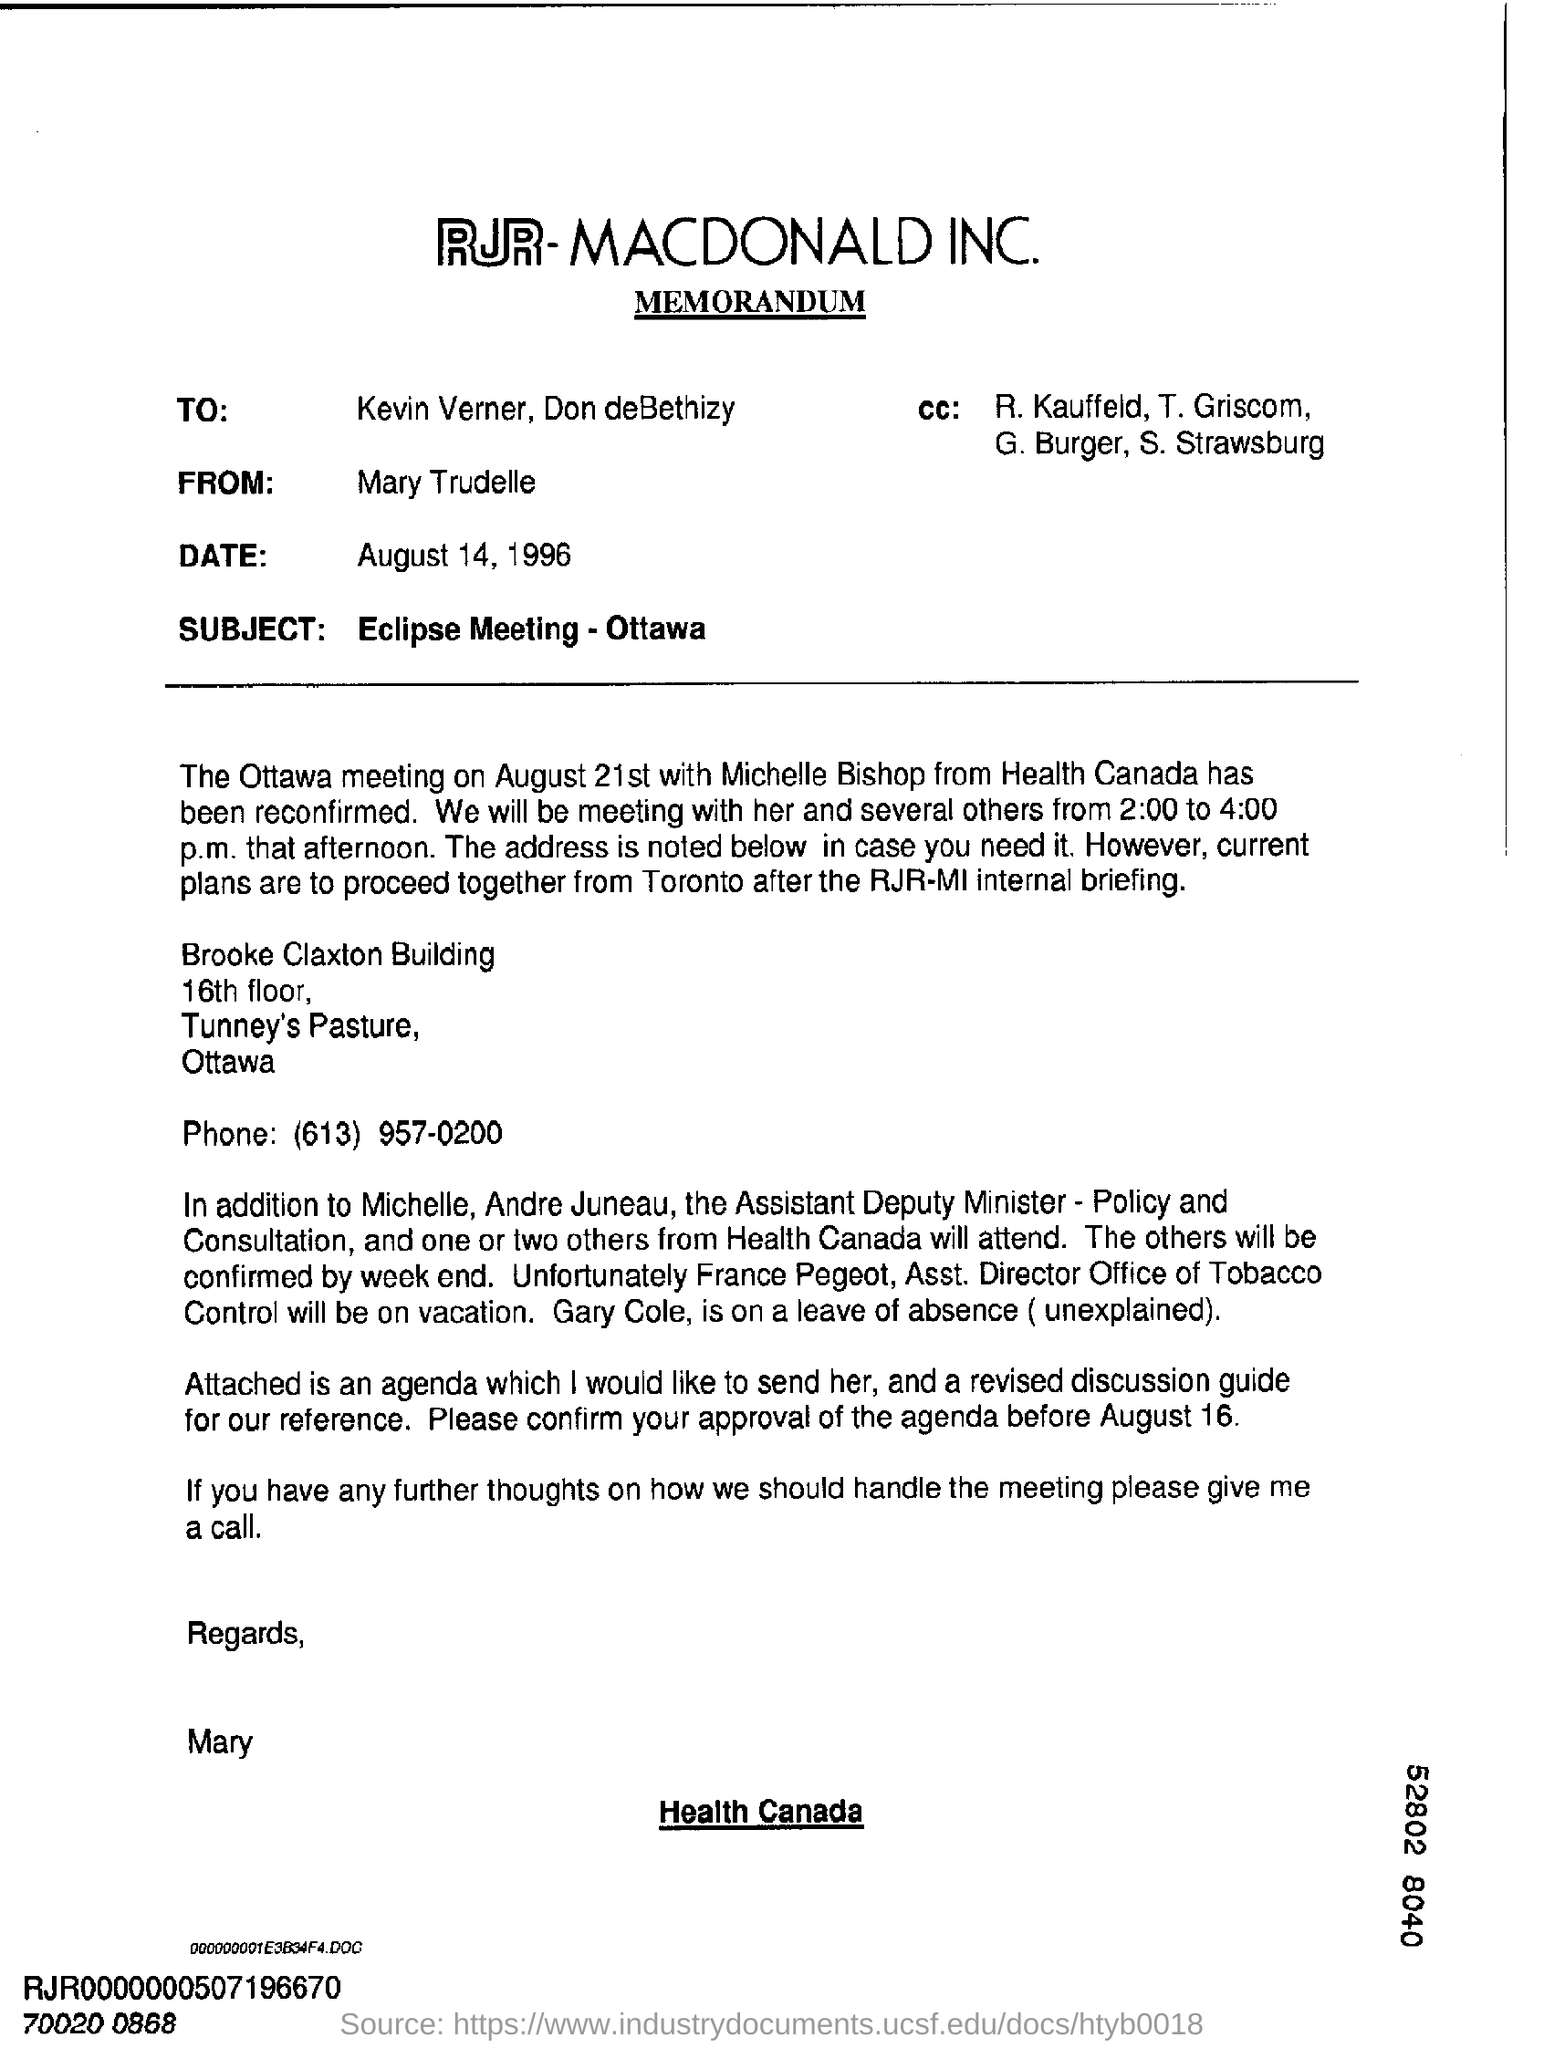Which company's memorandum in the document?
Ensure brevity in your answer.  RJR-MACDONALD INC. What is the date in the memorandum?
Keep it short and to the point. August 14, 1996. What is the subject of memorandum?
Your answer should be compact. Eclipse meeting - ottawa. On which day ottawa meeting with michelle bishop from health canada has been reconfirmed?
Your answer should be compact. August 21st. Who is the asssistant deputy minster?
Keep it short and to the point. Michelle, Andre Juneau. What is the designation of france pegeot, ?
Keep it short and to the point. Asst. director office of tobacco control. To whom mary trudelle writing this memorandum ?
Provide a succinct answer. Kevin Verner, Don deBethizy. 